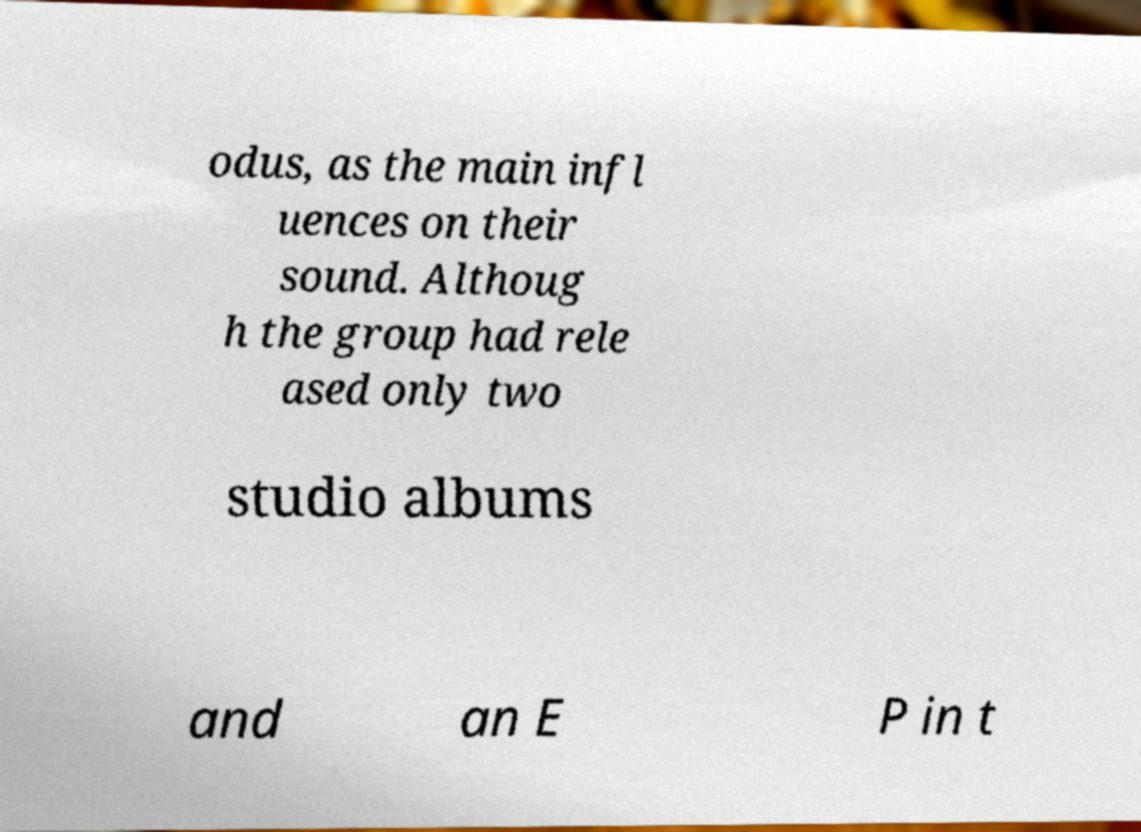Could you extract and type out the text from this image? odus, as the main infl uences on their sound. Althoug h the group had rele ased only two studio albums and an E P in t 